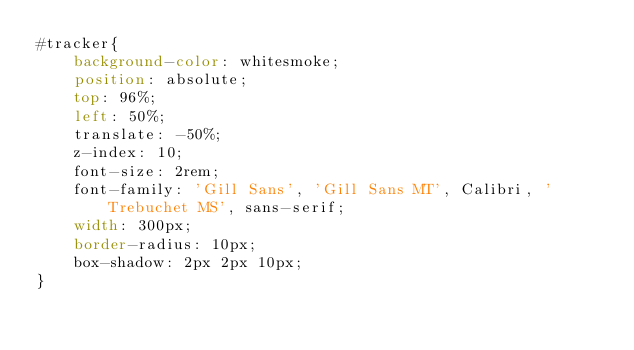<code> <loc_0><loc_0><loc_500><loc_500><_CSS_>#tracker{
    background-color: whitesmoke;
    position: absolute;
    top: 96%;
    left: 50%;
    translate: -50%;
    z-index: 10;
    font-size: 2rem;
    font-family: 'Gill Sans', 'Gill Sans MT', Calibri, 'Trebuchet MS', sans-serif;
    width: 300px;
    border-radius: 10px;
    box-shadow: 2px 2px 10px;
}</code> 